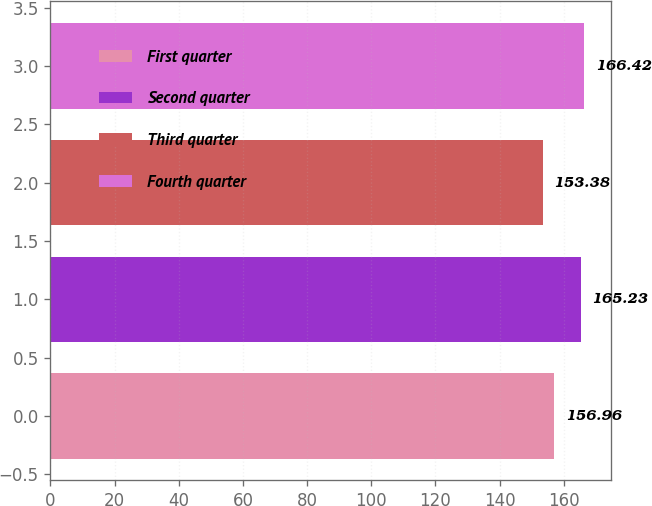Convert chart. <chart><loc_0><loc_0><loc_500><loc_500><bar_chart><fcel>First quarter<fcel>Second quarter<fcel>Third quarter<fcel>Fourth quarter<nl><fcel>156.96<fcel>165.23<fcel>153.38<fcel>166.42<nl></chart> 